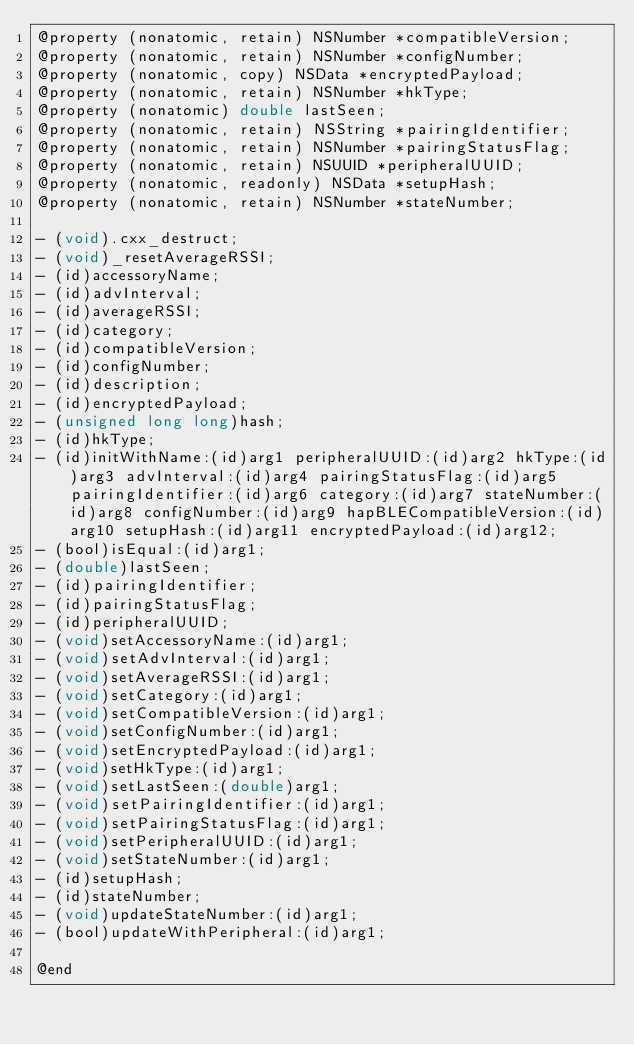Convert code to text. <code><loc_0><loc_0><loc_500><loc_500><_C_>@property (nonatomic, retain) NSNumber *compatibleVersion;
@property (nonatomic, retain) NSNumber *configNumber;
@property (nonatomic, copy) NSData *encryptedPayload;
@property (nonatomic, retain) NSNumber *hkType;
@property (nonatomic) double lastSeen;
@property (nonatomic, retain) NSString *pairingIdentifier;
@property (nonatomic, retain) NSNumber *pairingStatusFlag;
@property (nonatomic, retain) NSUUID *peripheralUUID;
@property (nonatomic, readonly) NSData *setupHash;
@property (nonatomic, retain) NSNumber *stateNumber;

- (void).cxx_destruct;
- (void)_resetAverageRSSI;
- (id)accessoryName;
- (id)advInterval;
- (id)averageRSSI;
- (id)category;
- (id)compatibleVersion;
- (id)configNumber;
- (id)description;
- (id)encryptedPayload;
- (unsigned long long)hash;
- (id)hkType;
- (id)initWithName:(id)arg1 peripheralUUID:(id)arg2 hkType:(id)arg3 advInterval:(id)arg4 pairingStatusFlag:(id)arg5 pairingIdentifier:(id)arg6 category:(id)arg7 stateNumber:(id)arg8 configNumber:(id)arg9 hapBLECompatibleVersion:(id)arg10 setupHash:(id)arg11 encryptedPayload:(id)arg12;
- (bool)isEqual:(id)arg1;
- (double)lastSeen;
- (id)pairingIdentifier;
- (id)pairingStatusFlag;
- (id)peripheralUUID;
- (void)setAccessoryName:(id)arg1;
- (void)setAdvInterval:(id)arg1;
- (void)setAverageRSSI:(id)arg1;
- (void)setCategory:(id)arg1;
- (void)setCompatibleVersion:(id)arg1;
- (void)setConfigNumber:(id)arg1;
- (void)setEncryptedPayload:(id)arg1;
- (void)setHkType:(id)arg1;
- (void)setLastSeen:(double)arg1;
- (void)setPairingIdentifier:(id)arg1;
- (void)setPairingStatusFlag:(id)arg1;
- (void)setPeripheralUUID:(id)arg1;
- (void)setStateNumber:(id)arg1;
- (id)setupHash;
- (id)stateNumber;
- (void)updateStateNumber:(id)arg1;
- (bool)updateWithPeripheral:(id)arg1;

@end
</code> 